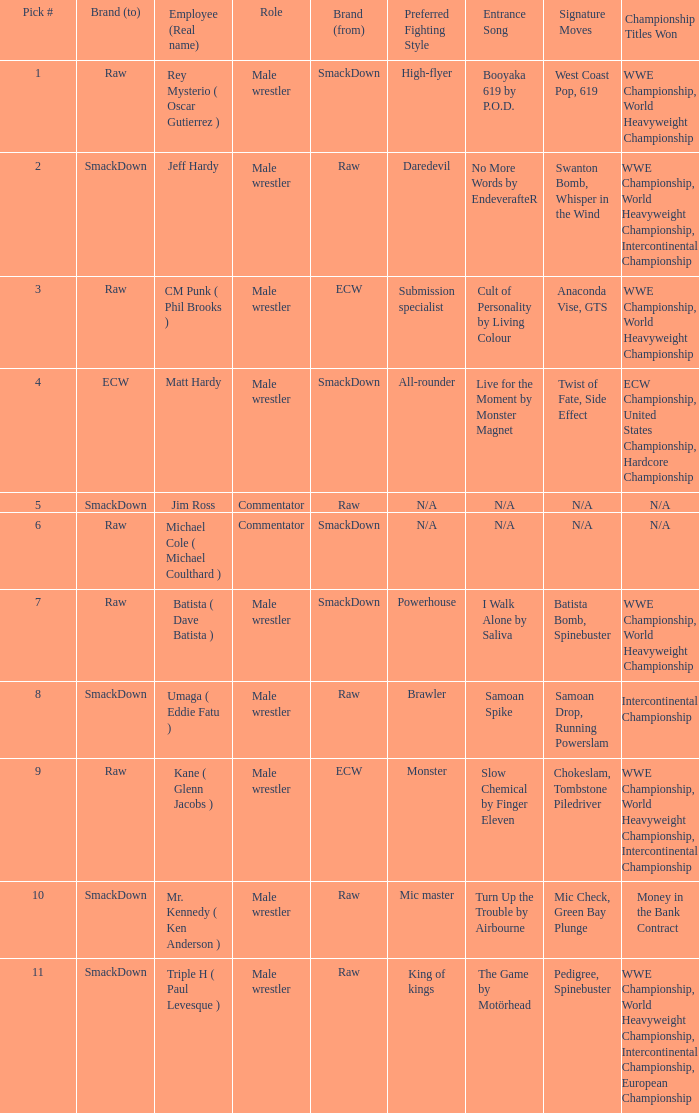What is the real name of the male wrestler from Raw with a pick # smaller than 6? Jeff Hardy. 